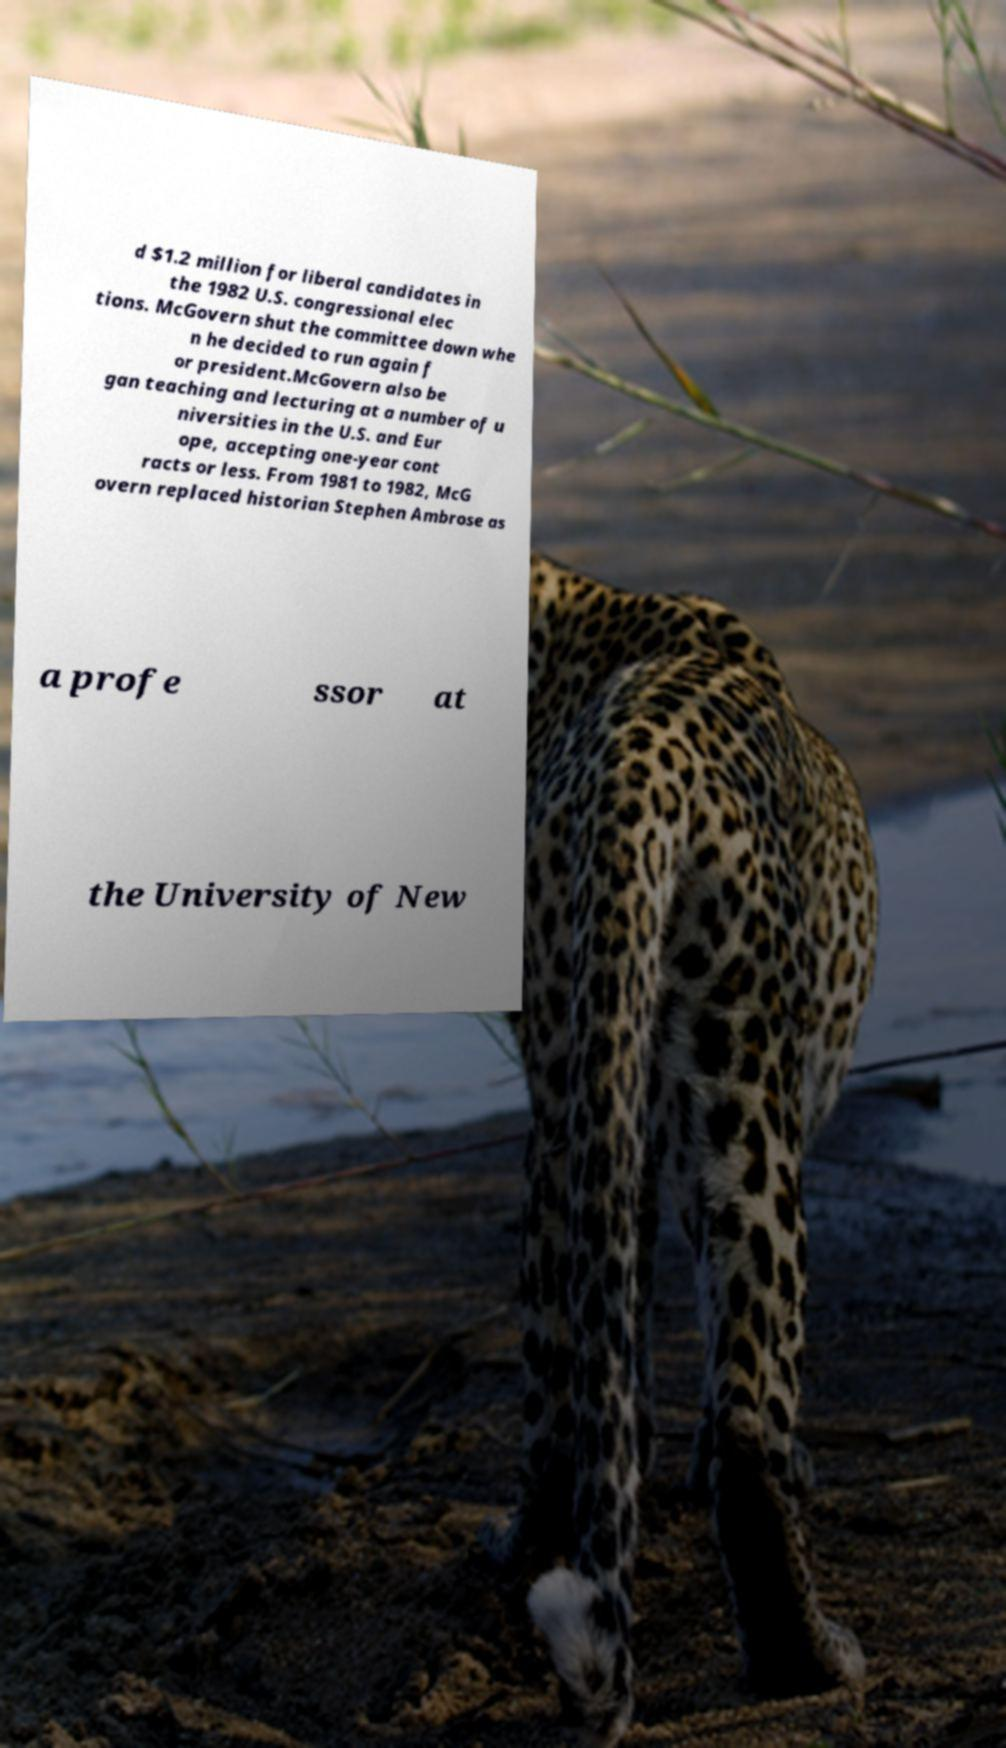Can you accurately transcribe the text from the provided image for me? d $1.2 million for liberal candidates in the 1982 U.S. congressional elec tions. McGovern shut the committee down whe n he decided to run again f or president.McGovern also be gan teaching and lecturing at a number of u niversities in the U.S. and Eur ope, accepting one-year cont racts or less. From 1981 to 1982, McG overn replaced historian Stephen Ambrose as a profe ssor at the University of New 